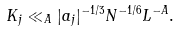Convert formula to latex. <formula><loc_0><loc_0><loc_500><loc_500>K _ { j } \ll _ { A } | a _ { j } | ^ { - 1 / 3 } N ^ { - 1 / 6 } L ^ { - A } .</formula> 